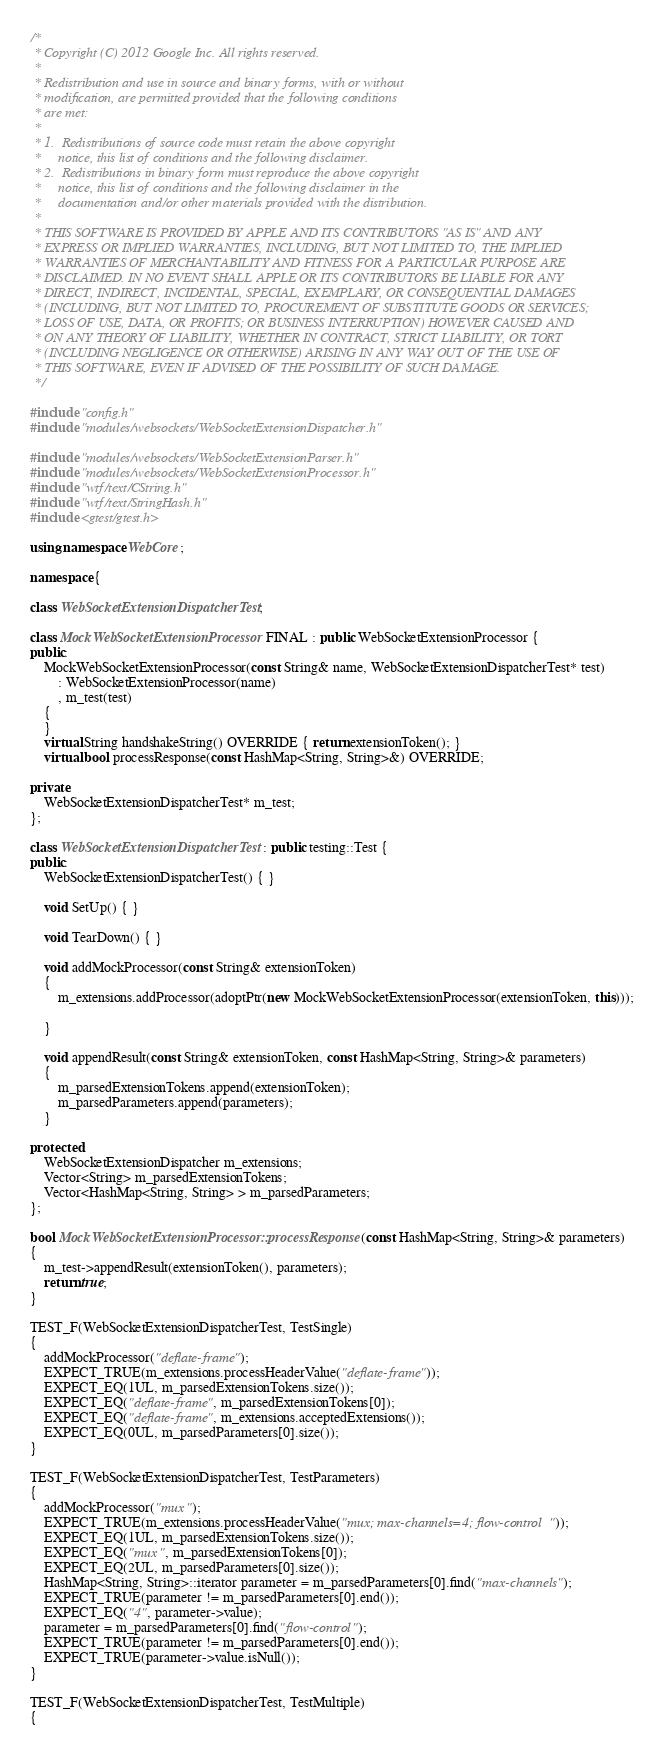<code> <loc_0><loc_0><loc_500><loc_500><_C++_>/*
 * Copyright (C) 2012 Google Inc. All rights reserved.
 *
 * Redistribution and use in source and binary forms, with or without
 * modification, are permitted provided that the following conditions
 * are met:
 *
 * 1.  Redistributions of source code must retain the above copyright
 *     notice, this list of conditions and the following disclaimer.
 * 2.  Redistributions in binary form must reproduce the above copyright
 *     notice, this list of conditions and the following disclaimer in the
 *     documentation and/or other materials provided with the distribution.
 *
 * THIS SOFTWARE IS PROVIDED BY APPLE AND ITS CONTRIBUTORS "AS IS" AND ANY
 * EXPRESS OR IMPLIED WARRANTIES, INCLUDING, BUT NOT LIMITED TO, THE IMPLIED
 * WARRANTIES OF MERCHANTABILITY AND FITNESS FOR A PARTICULAR PURPOSE ARE
 * DISCLAIMED. IN NO EVENT SHALL APPLE OR ITS CONTRIBUTORS BE LIABLE FOR ANY
 * DIRECT, INDIRECT, INCIDENTAL, SPECIAL, EXEMPLARY, OR CONSEQUENTIAL DAMAGES
 * (INCLUDING, BUT NOT LIMITED TO, PROCUREMENT OF SUBSTITUTE GOODS OR SERVICES;
 * LOSS OF USE, DATA, OR PROFITS; OR BUSINESS INTERRUPTION) HOWEVER CAUSED AND
 * ON ANY THEORY OF LIABILITY, WHETHER IN CONTRACT, STRICT LIABILITY, OR TORT
 * (INCLUDING NEGLIGENCE OR OTHERWISE) ARISING IN ANY WAY OUT OF THE USE OF
 * THIS SOFTWARE, EVEN IF ADVISED OF THE POSSIBILITY OF SUCH DAMAGE.
 */

#include "config.h"
#include "modules/websockets/WebSocketExtensionDispatcher.h"

#include "modules/websockets/WebSocketExtensionParser.h"
#include "modules/websockets/WebSocketExtensionProcessor.h"
#include "wtf/text/CString.h"
#include "wtf/text/StringHash.h"
#include <gtest/gtest.h>

using namespace WebCore;

namespace {

class WebSocketExtensionDispatcherTest;

class MockWebSocketExtensionProcessor FINAL : public WebSocketExtensionProcessor {
public:
    MockWebSocketExtensionProcessor(const String& name, WebSocketExtensionDispatcherTest* test)
        : WebSocketExtensionProcessor(name)
        , m_test(test)
    {
    }
    virtual String handshakeString() OVERRIDE { return extensionToken(); }
    virtual bool processResponse(const HashMap<String, String>&) OVERRIDE;

private:
    WebSocketExtensionDispatcherTest* m_test;
};

class WebSocketExtensionDispatcherTest : public testing::Test {
public:
    WebSocketExtensionDispatcherTest() { }

    void SetUp() { }

    void TearDown() { }

    void addMockProcessor(const String& extensionToken)
    {
        m_extensions.addProcessor(adoptPtr(new MockWebSocketExtensionProcessor(extensionToken, this)));

    }

    void appendResult(const String& extensionToken, const HashMap<String, String>& parameters)
    {
        m_parsedExtensionTokens.append(extensionToken);
        m_parsedParameters.append(parameters);
    }

protected:
    WebSocketExtensionDispatcher m_extensions;
    Vector<String> m_parsedExtensionTokens;
    Vector<HashMap<String, String> > m_parsedParameters;
};

bool MockWebSocketExtensionProcessor::processResponse(const HashMap<String, String>& parameters)
{
    m_test->appendResult(extensionToken(), parameters);
    return true;
}

TEST_F(WebSocketExtensionDispatcherTest, TestSingle)
{
    addMockProcessor("deflate-frame");
    EXPECT_TRUE(m_extensions.processHeaderValue("deflate-frame"));
    EXPECT_EQ(1UL, m_parsedExtensionTokens.size());
    EXPECT_EQ("deflate-frame", m_parsedExtensionTokens[0]);
    EXPECT_EQ("deflate-frame", m_extensions.acceptedExtensions());
    EXPECT_EQ(0UL, m_parsedParameters[0].size());
}

TEST_F(WebSocketExtensionDispatcherTest, TestParameters)
{
    addMockProcessor("mux");
    EXPECT_TRUE(m_extensions.processHeaderValue("mux; max-channels=4; flow-control  "));
    EXPECT_EQ(1UL, m_parsedExtensionTokens.size());
    EXPECT_EQ("mux", m_parsedExtensionTokens[0]);
    EXPECT_EQ(2UL, m_parsedParameters[0].size());
    HashMap<String, String>::iterator parameter = m_parsedParameters[0].find("max-channels");
    EXPECT_TRUE(parameter != m_parsedParameters[0].end());
    EXPECT_EQ("4", parameter->value);
    parameter = m_parsedParameters[0].find("flow-control");
    EXPECT_TRUE(parameter != m_parsedParameters[0].end());
    EXPECT_TRUE(parameter->value.isNull());
}

TEST_F(WebSocketExtensionDispatcherTest, TestMultiple)
{</code> 